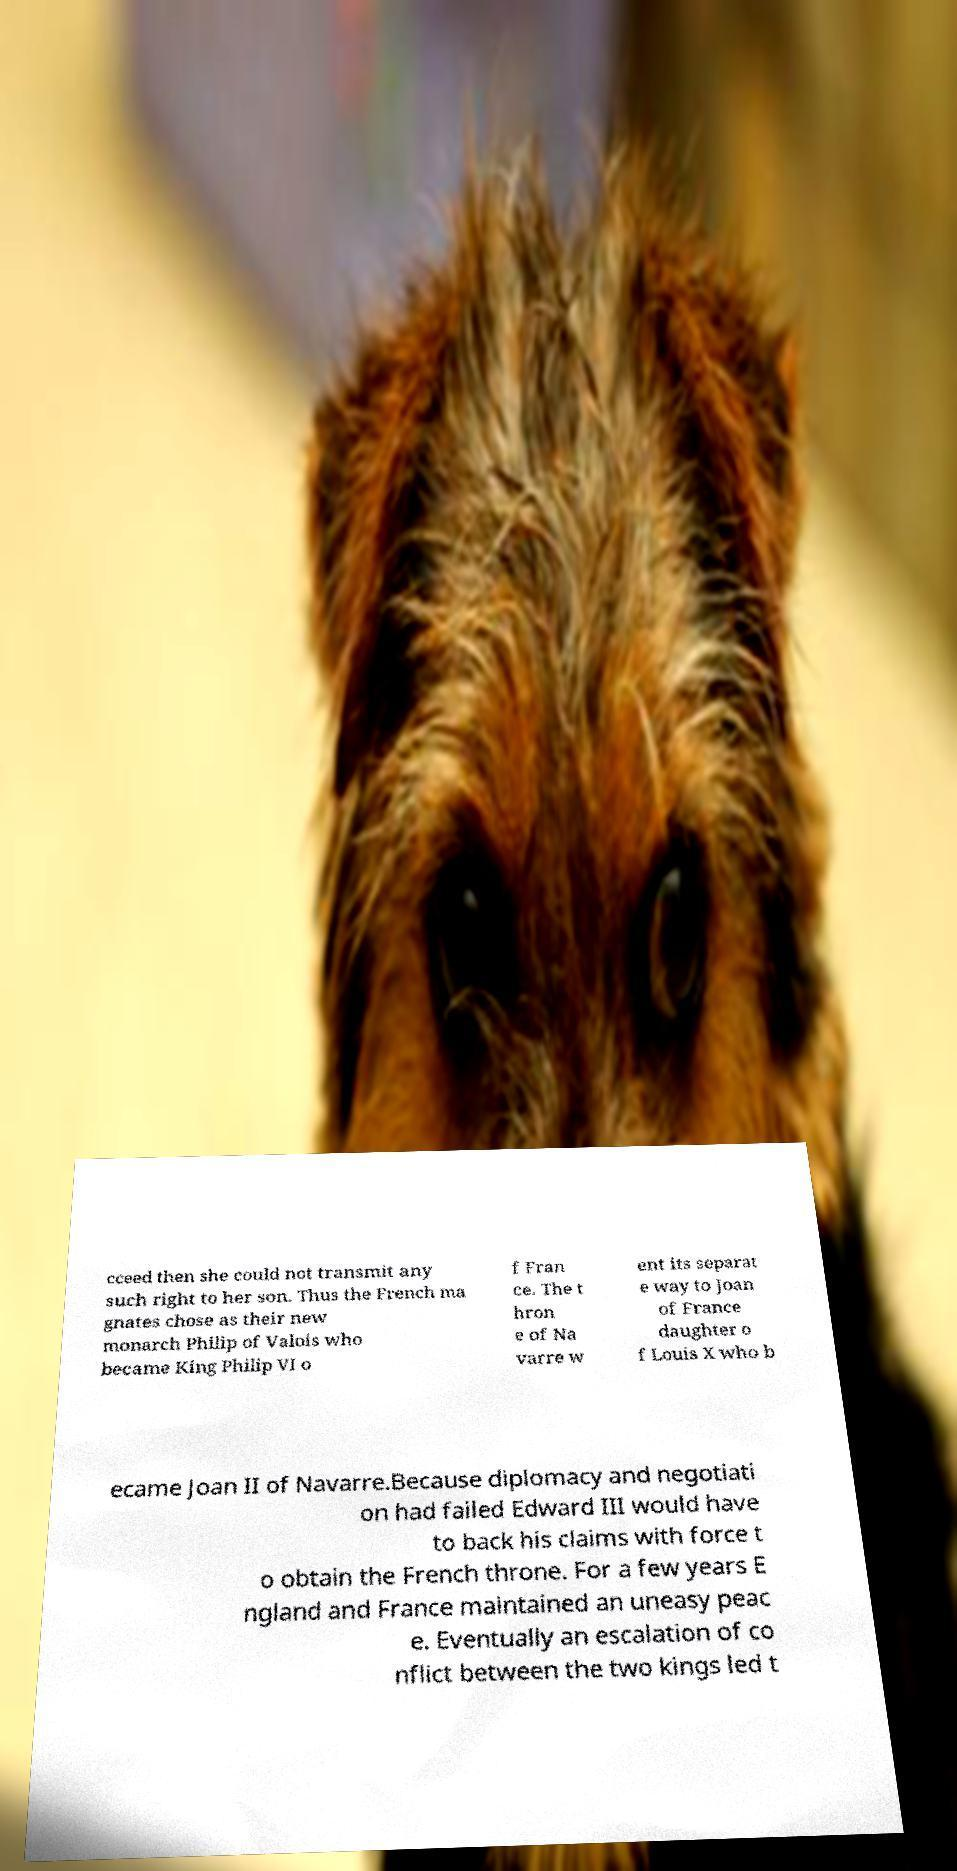Please read and relay the text visible in this image. What does it say? cceed then she could not transmit any such right to her son. Thus the French ma gnates chose as their new monarch Philip of Valois who became King Philip VI o f Fran ce. The t hron e of Na varre w ent its separat e way to Joan of France daughter o f Louis X who b ecame Joan II of Navarre.Because diplomacy and negotiati on had failed Edward III would have to back his claims with force t o obtain the French throne. For a few years E ngland and France maintained an uneasy peac e. Eventually an escalation of co nflict between the two kings led t 